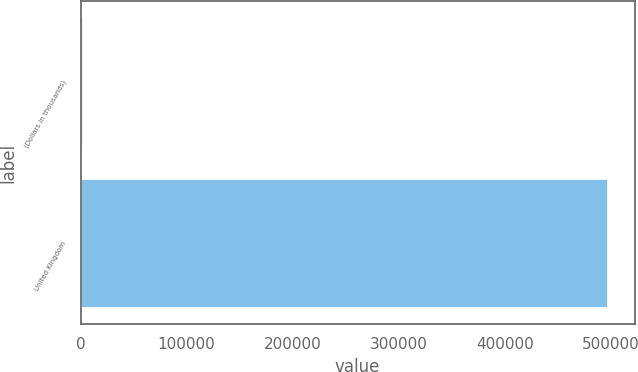Convert chart. <chart><loc_0><loc_0><loc_500><loc_500><bar_chart><fcel>(Dollars in thousands)<fcel>United Kingdom<nl><fcel>2009<fcel>497595<nl></chart> 